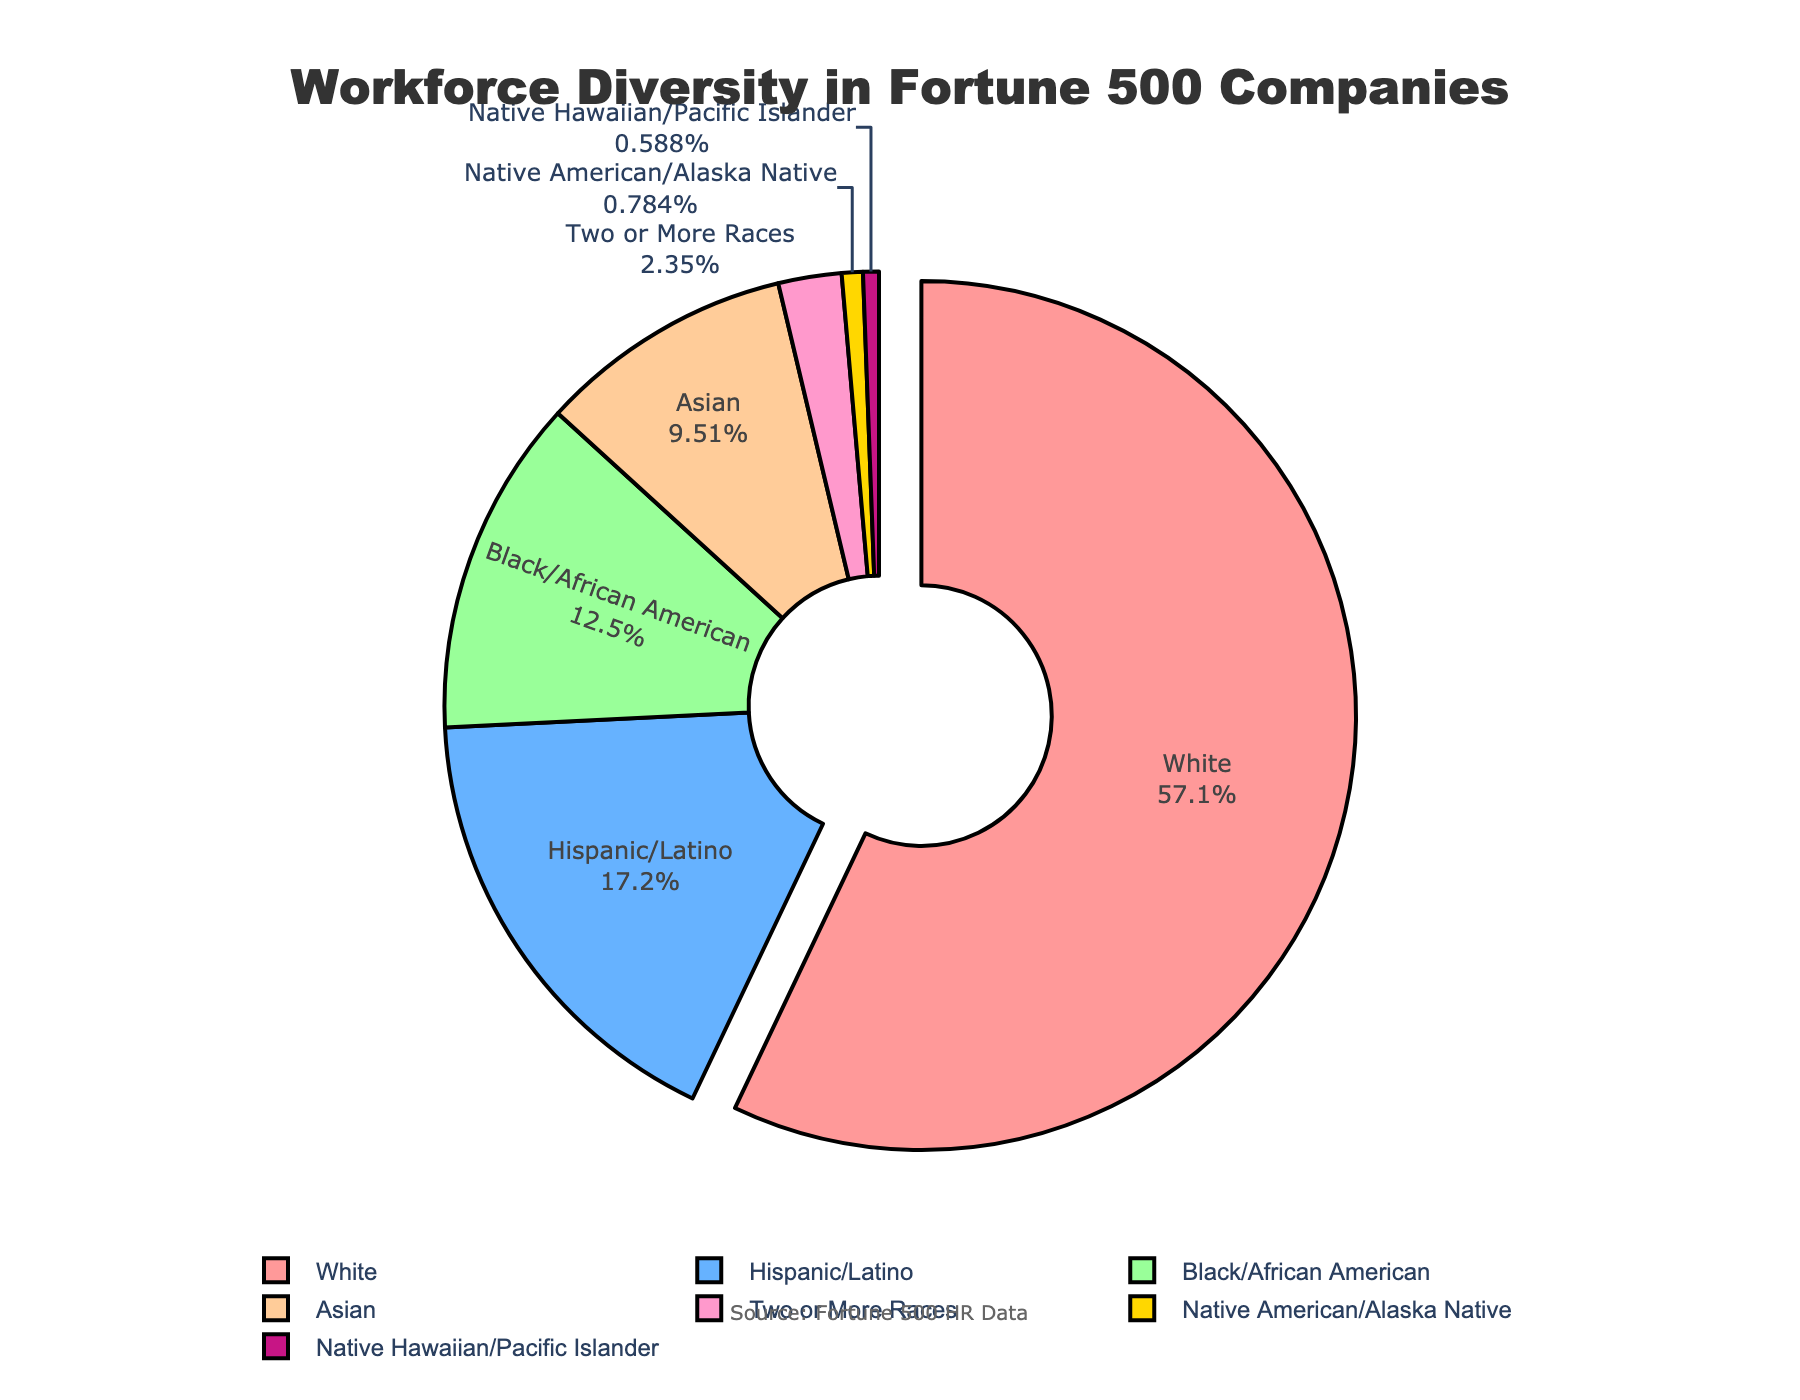What is the largest demographic category in the workforce diversity of Fortune 500 companies? The largest demographic category is highlighted in the pie chart by being slightly pulled out from the rest of the pie segments. According to the data, it is White, represented at 58.2%.
Answer: White What percentage of the workforce does the Hispanic/Latino demographic represent? By looking at the segment labeled 'Hispanic/Latino' in the pie chart, we can see the percentage associated with it. According to the chart, it is 17.5%.
Answer: 17.5% How do the percentages of the Asian and Black/African American demographics compare? From the pie chart, the percentage for Asian is 9.7%, and for Black/African American, it is 12.8%. Therefore, Black/African American has a higher percentage than Asian.
Answer: Black/African American has a higher percentage What is the combined percentage of Native American/Alaska Native and Native Hawaiian/Pacific Islander demographics? The pie chart shows that Native American/Alaska Native makes up 0.8% and Native Hawaiian/Pacific Islander makes up 0.6%. Adding these together, 0.8% + 0.6% = 1.4%.
Answer: 1.4% Which demographic categories make up less than 10% each of the workforce? According to the pie chart, the demographics that make up less than 10% each are Asian (9.7%), Two or More Races (2.4%), Native American/Alaska Native (0.8%), and Native Hawaiian/Pacific Islander (0.6%).
Answer: Asian, Two or More Races, Native American/Alaska Native, Native Hawaiian/Pacific Islander Which segment is represented in red, and what percentage does it account for? The color red is assigned visually to one of the segments. By referencing the chart, we see that red corresponds to White, which accounts for 58.2% of the workforce.
Answer: White, 58.2% What is the difference in percentage points between the Hispanic/Latino and Two or More Races demographics? From the pie chart data, the Hispanic/Latino demographic is at 17.5%, and Two or More Races is at 2.4%. The difference is calculated as 17.5% - 2.4% = 15.1%.
Answer: 15.1% What is the second largest demographic category, and what percentage does it represent? The pie chart shows that after White (58.2%), the next largest demographic category is Hispanic/Latino, representing 17.5%.
Answer: Hispanic/Latino, 17.5% Which demographic is the least represented and what is its percentage? The pie chart indicates that the least represented demographic category is Native Hawaiian/Pacific Islander at 0.6%.
Answer: Native Hawaiian/Pacific Islander, 0.6% What is the total percentage of all non-White demographic categories combined? By summing up the percentages of all non-White demographics: Hispanic/Latino (17.5%) + Black/African American (12.8%) + Asian (9.7%) + Two or More Races (2.4%) + Native American/Alaska Native (0.8%) + Native Hawaiian/Pacific Islander (0.6%), the total is 43.6%.
Answer: 43.6% 